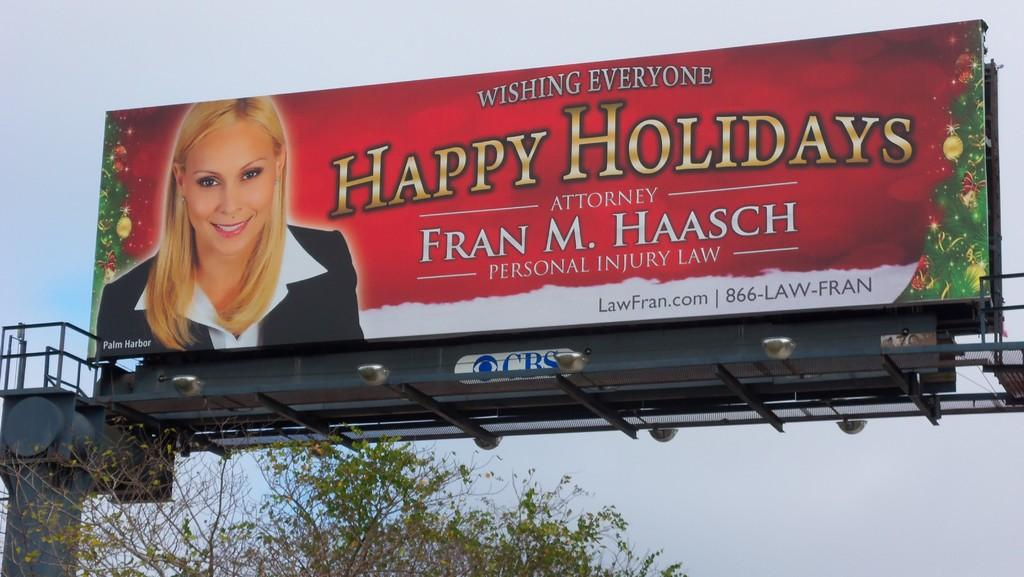<image>
Render a clear and concise summary of the photo. a sign with a lady wishing everyone a happy holiday 